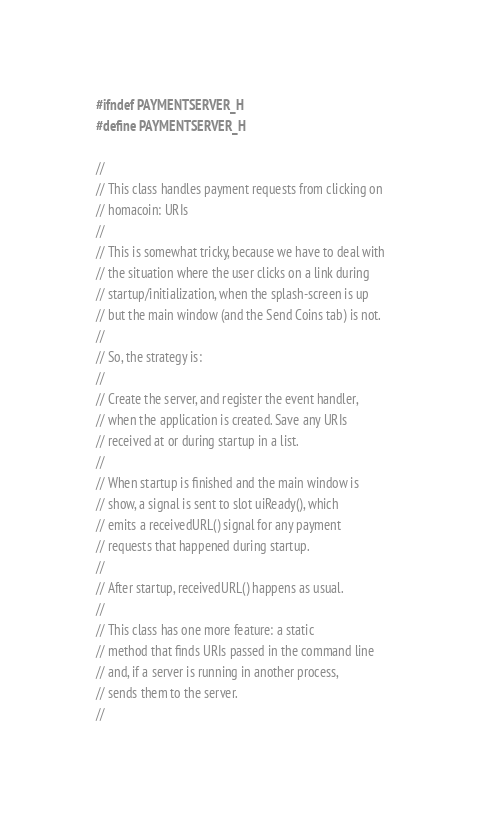Convert code to text. <code><loc_0><loc_0><loc_500><loc_500><_C_>#ifndef PAYMENTSERVER_H
#define PAYMENTSERVER_H

//
// This class handles payment requests from clicking on
// homacoin: URIs
//
// This is somewhat tricky, because we have to deal with
// the situation where the user clicks on a link during
// startup/initialization, when the splash-screen is up
// but the main window (and the Send Coins tab) is not.
//
// So, the strategy is:
//
// Create the server, and register the event handler,
// when the application is created. Save any URIs
// received at or during startup in a list.
//
// When startup is finished and the main window is
// show, a signal is sent to slot uiReady(), which
// emits a receivedURL() signal for any payment
// requests that happened during startup.
//
// After startup, receivedURL() happens as usual.
//
// This class has one more feature: a static
// method that finds URIs passed in the command line
// and, if a server is running in another process,
// sends them to the server.
//</code> 